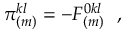<formula> <loc_0><loc_0><loc_500><loc_500>\pi _ { ( m ) } ^ { k l } = - F _ { ( m ) } ^ { 0 k l } \, ,</formula> 